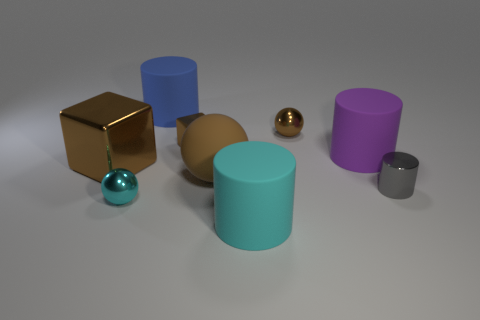Subtract all cyan cylinders. Subtract all cyan cubes. How many cylinders are left? 3 Add 1 cyan metallic objects. How many objects exist? 10 Subtract all blocks. How many objects are left? 7 Subtract 1 brown spheres. How many objects are left? 8 Subtract all big red shiny spheres. Subtract all big blue cylinders. How many objects are left? 8 Add 6 purple matte cylinders. How many purple matte cylinders are left? 7 Add 6 yellow metallic things. How many yellow metallic things exist? 6 